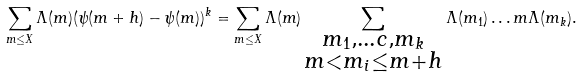Convert formula to latex. <formula><loc_0><loc_0><loc_500><loc_500>\sum _ { m \leq X } \Lambda ( m ) ( \psi ( m + h ) - \psi ( m ) ) ^ { k } = \sum _ { m \leq X } \Lambda ( m ) \sum _ { \substack { { m _ { 1 } , \dots c , m _ { k } } \\ m < m _ { i } \leq m + h } } \Lambda ( m _ { 1 } ) \dots m \Lambda ( m _ { k } ) .</formula> 